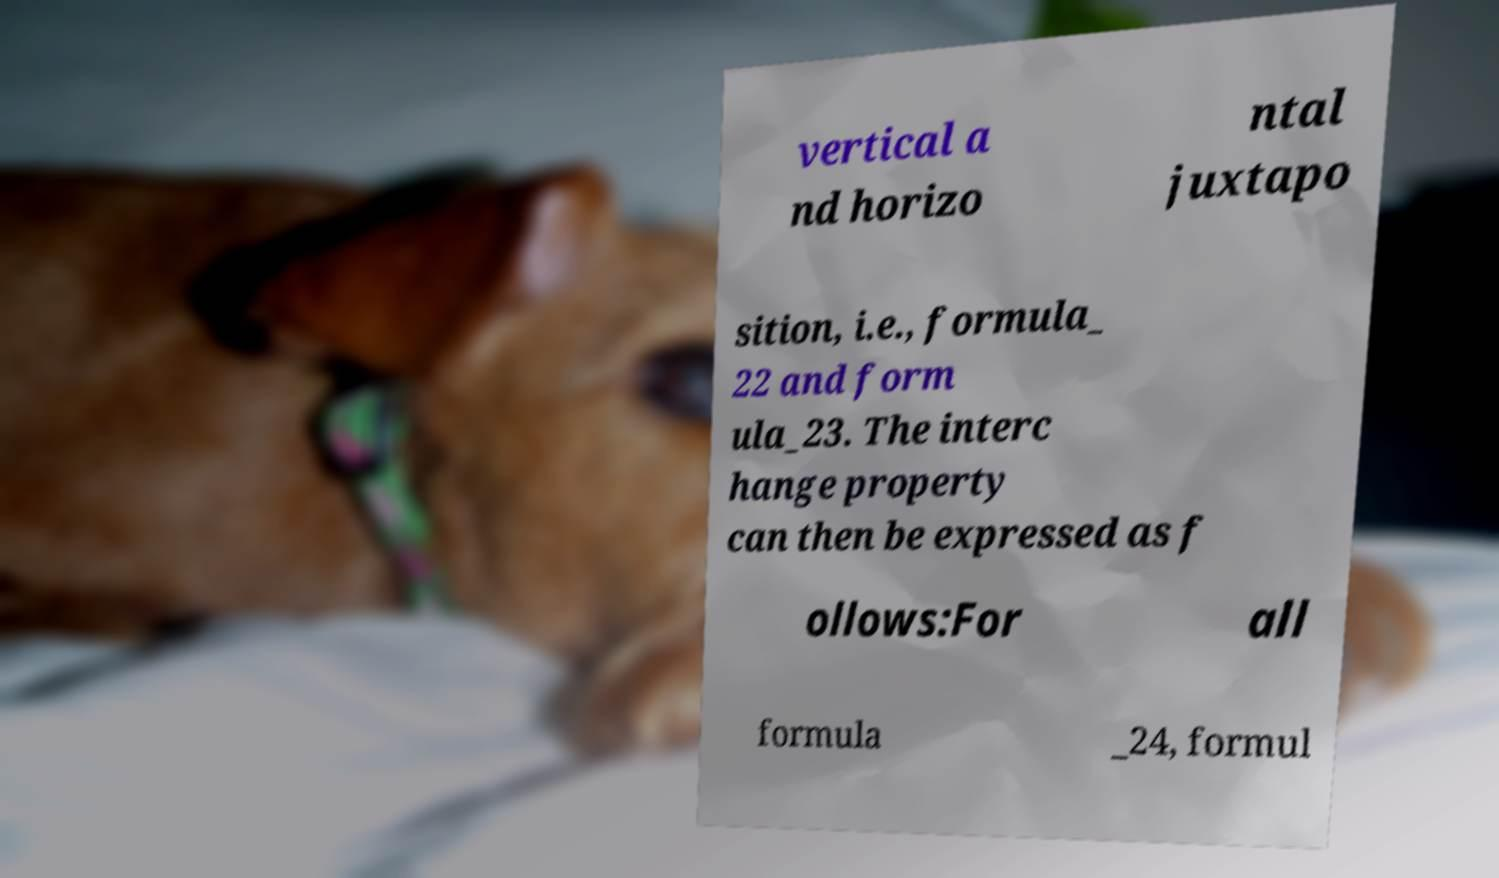Can you read and provide the text displayed in the image?This photo seems to have some interesting text. Can you extract and type it out for me? vertical a nd horizo ntal juxtapo sition, i.e., formula_ 22 and form ula_23. The interc hange property can then be expressed as f ollows:For all formula _24, formul 